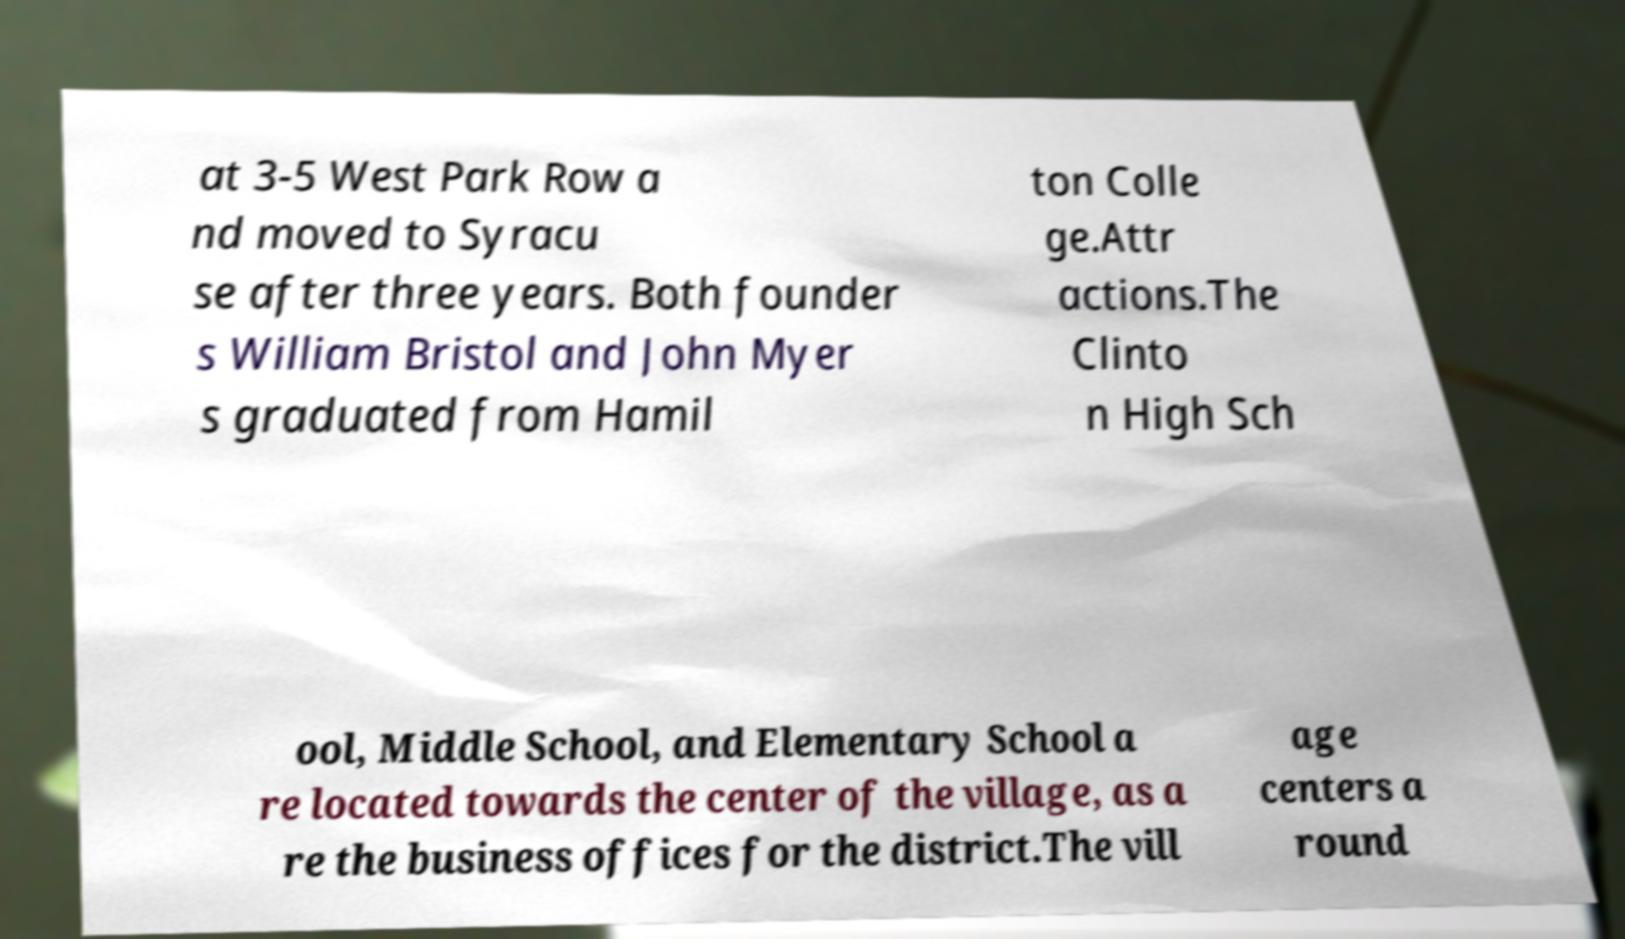Please identify and transcribe the text found in this image. at 3-5 West Park Row a nd moved to Syracu se after three years. Both founder s William Bristol and John Myer s graduated from Hamil ton Colle ge.Attr actions.The Clinto n High Sch ool, Middle School, and Elementary School a re located towards the center of the village, as a re the business offices for the district.The vill age centers a round 